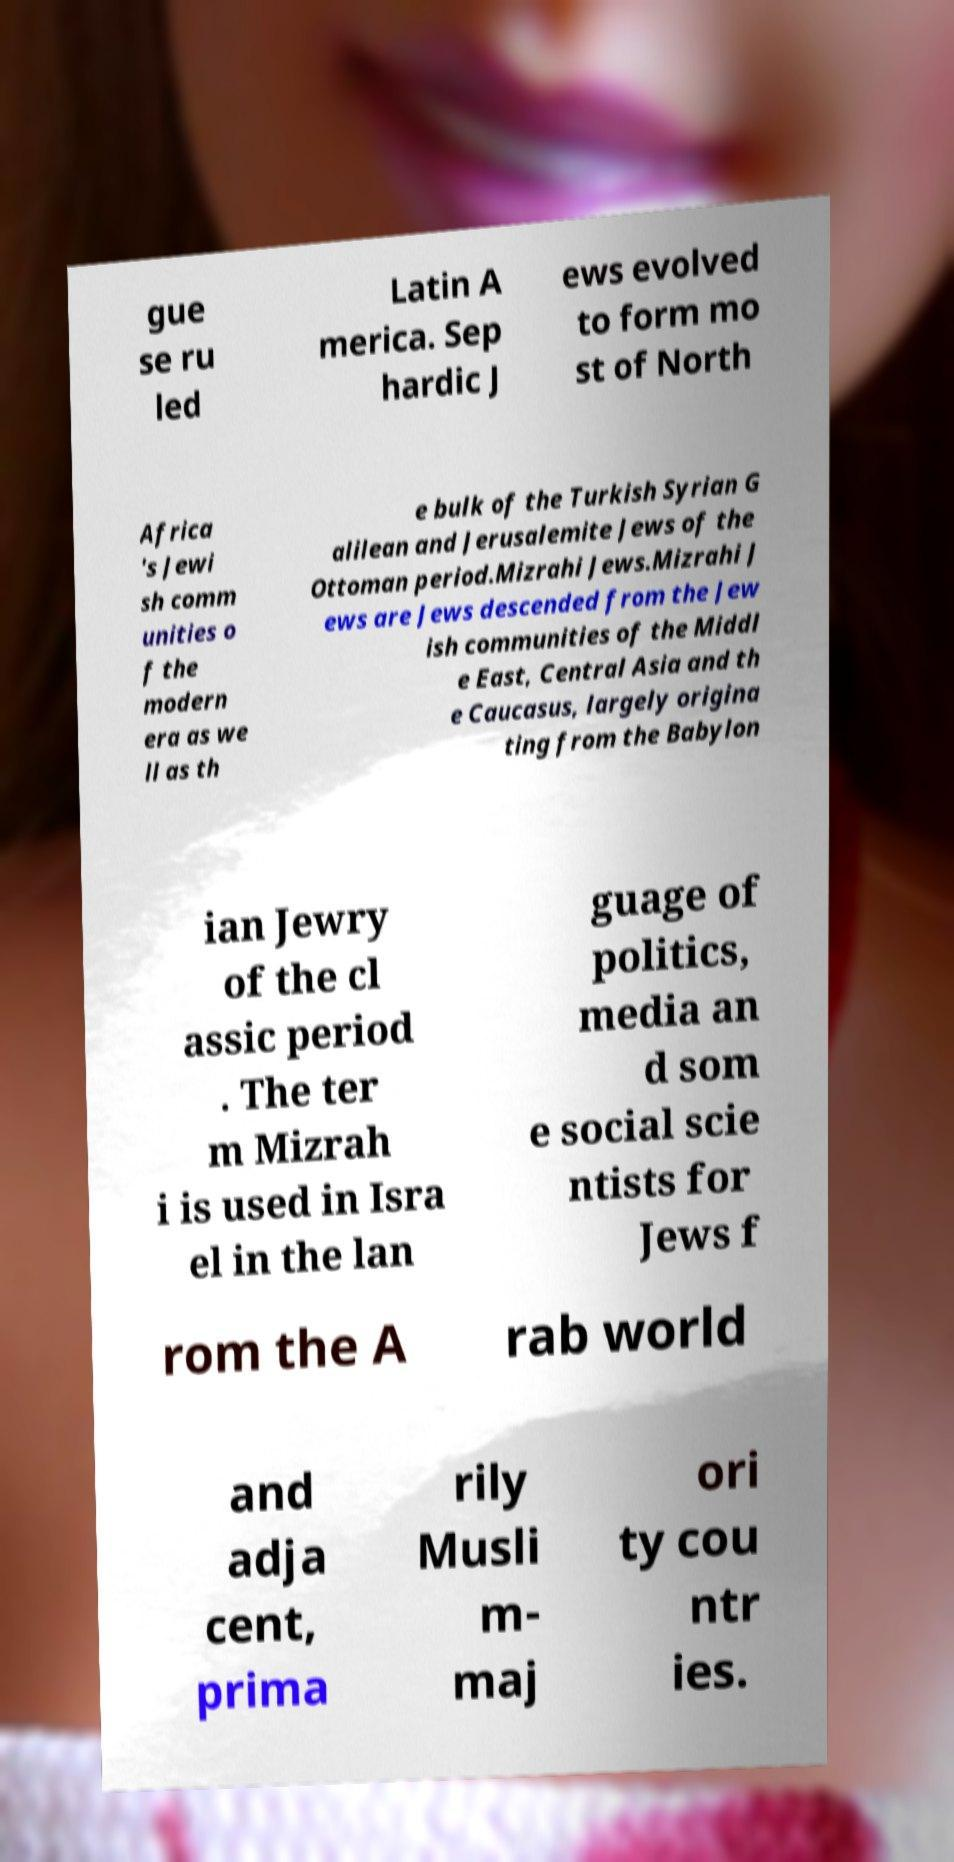Can you accurately transcribe the text from the provided image for me? gue se ru led Latin A merica. Sep hardic J ews evolved to form mo st of North Africa 's Jewi sh comm unities o f the modern era as we ll as th e bulk of the Turkish Syrian G alilean and Jerusalemite Jews of the Ottoman period.Mizrahi Jews.Mizrahi J ews are Jews descended from the Jew ish communities of the Middl e East, Central Asia and th e Caucasus, largely origina ting from the Babylon ian Jewry of the cl assic period . The ter m Mizrah i is used in Isra el in the lan guage of politics, media an d som e social scie ntists for Jews f rom the A rab world and adja cent, prima rily Musli m- maj ori ty cou ntr ies. 